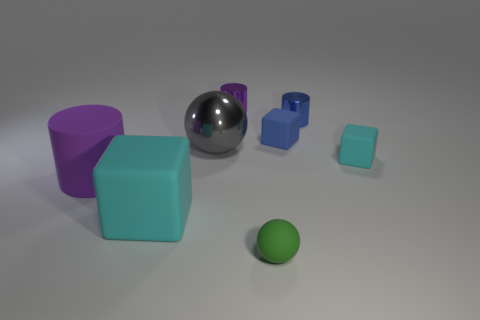What size is the other cyan object that is the same shape as the tiny cyan matte thing?
Provide a short and direct response. Large. Is there a small thing that has the same color as the small rubber sphere?
Your answer should be very brief. No. There is another cube that is the same color as the large cube; what is it made of?
Give a very brief answer. Rubber. What number of tiny rubber blocks are the same color as the large cube?
Ensure brevity in your answer.  1. How many things are either blocks in front of the purple matte cylinder or cyan rubber cubes?
Keep it short and to the point. 2. There is a big block that is the same material as the small green object; what is its color?
Keep it short and to the point. Cyan. Is there a metallic cylinder of the same size as the gray shiny thing?
Offer a very short reply. No. What number of things are things right of the small green object or small matte objects right of the tiny green rubber ball?
Provide a succinct answer. 3. The purple shiny object that is the same size as the green rubber ball is what shape?
Provide a succinct answer. Cylinder. Is there another large thing that has the same shape as the blue metallic object?
Offer a very short reply. Yes. 